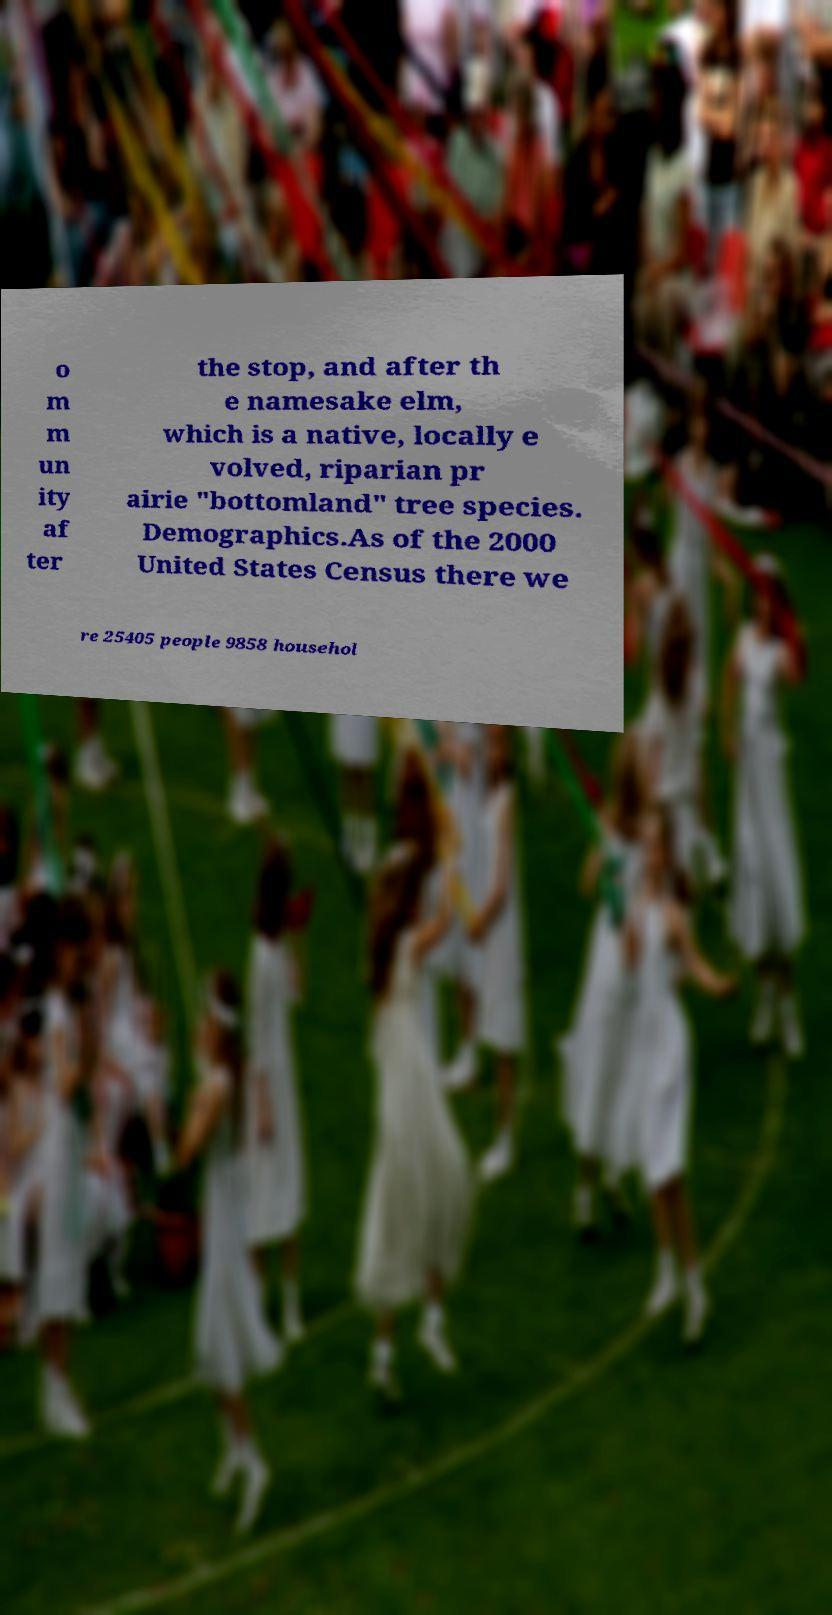Could you assist in decoding the text presented in this image and type it out clearly? o m m un ity af ter the stop, and after th e namesake elm, which is a native, locally e volved, riparian pr airie "bottomland" tree species. Demographics.As of the 2000 United States Census there we re 25405 people 9858 househol 